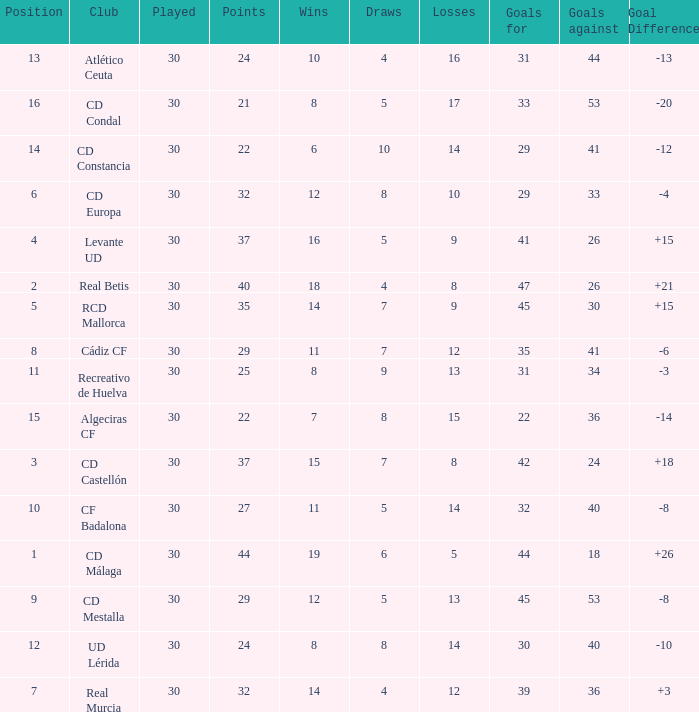What is the number of draws when played is smaller than 30? 0.0. 